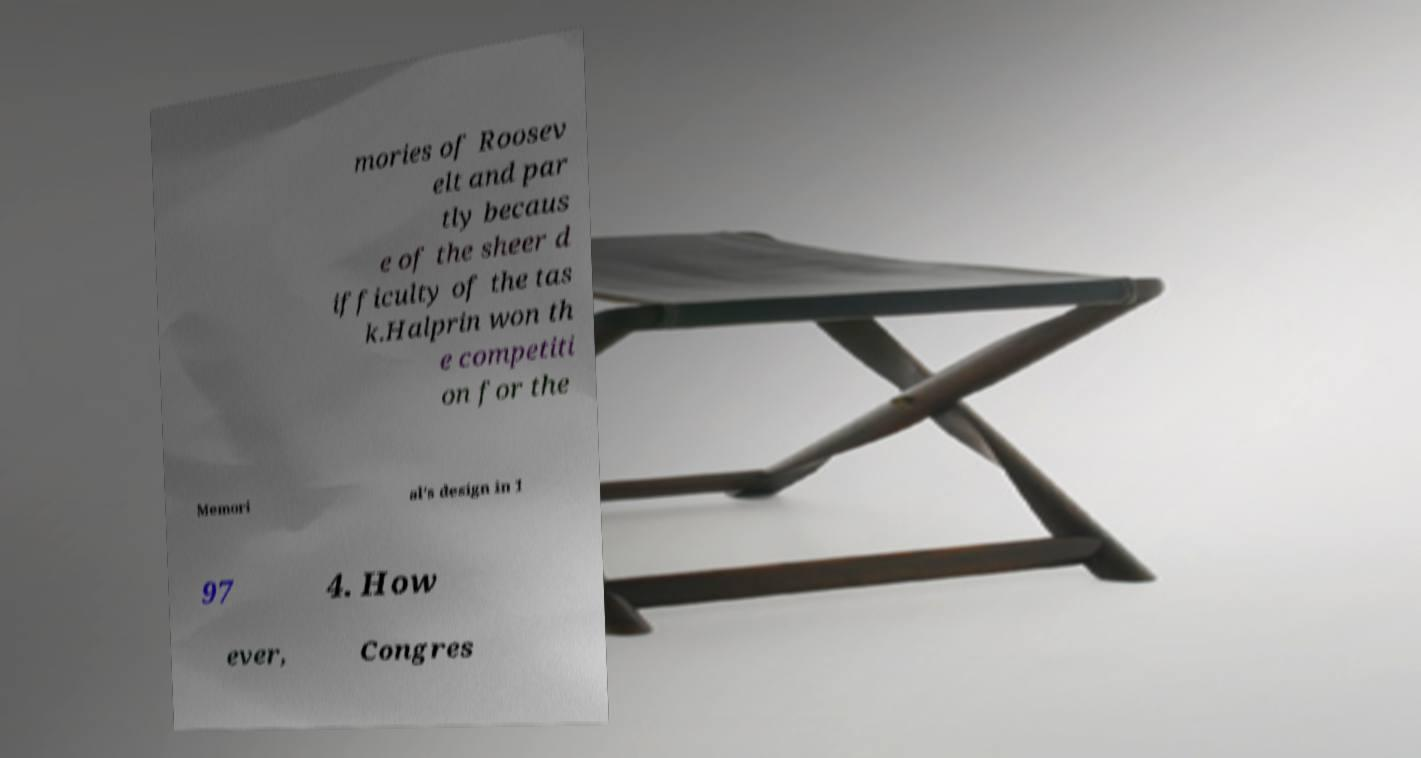For documentation purposes, I need the text within this image transcribed. Could you provide that? mories of Roosev elt and par tly becaus e of the sheer d ifficulty of the tas k.Halprin won th e competiti on for the Memori al's design in 1 97 4. How ever, Congres 